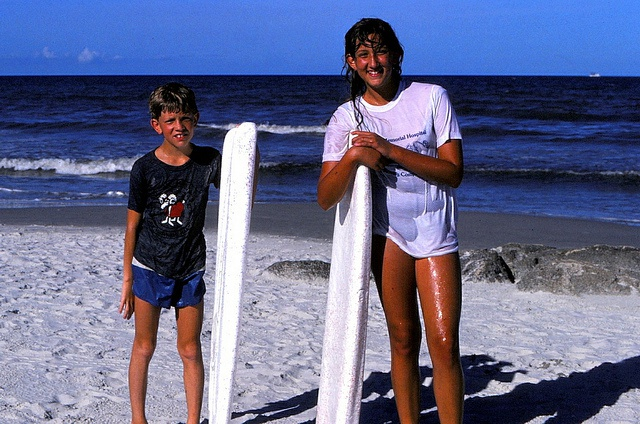Describe the objects in this image and their specific colors. I can see people in blue, black, maroon, lavender, and darkgray tones, people in blue, black, brown, navy, and maroon tones, surfboard in blue, lavender, gray, and darkgray tones, and surfboard in blue, white, darkgray, and lavender tones in this image. 